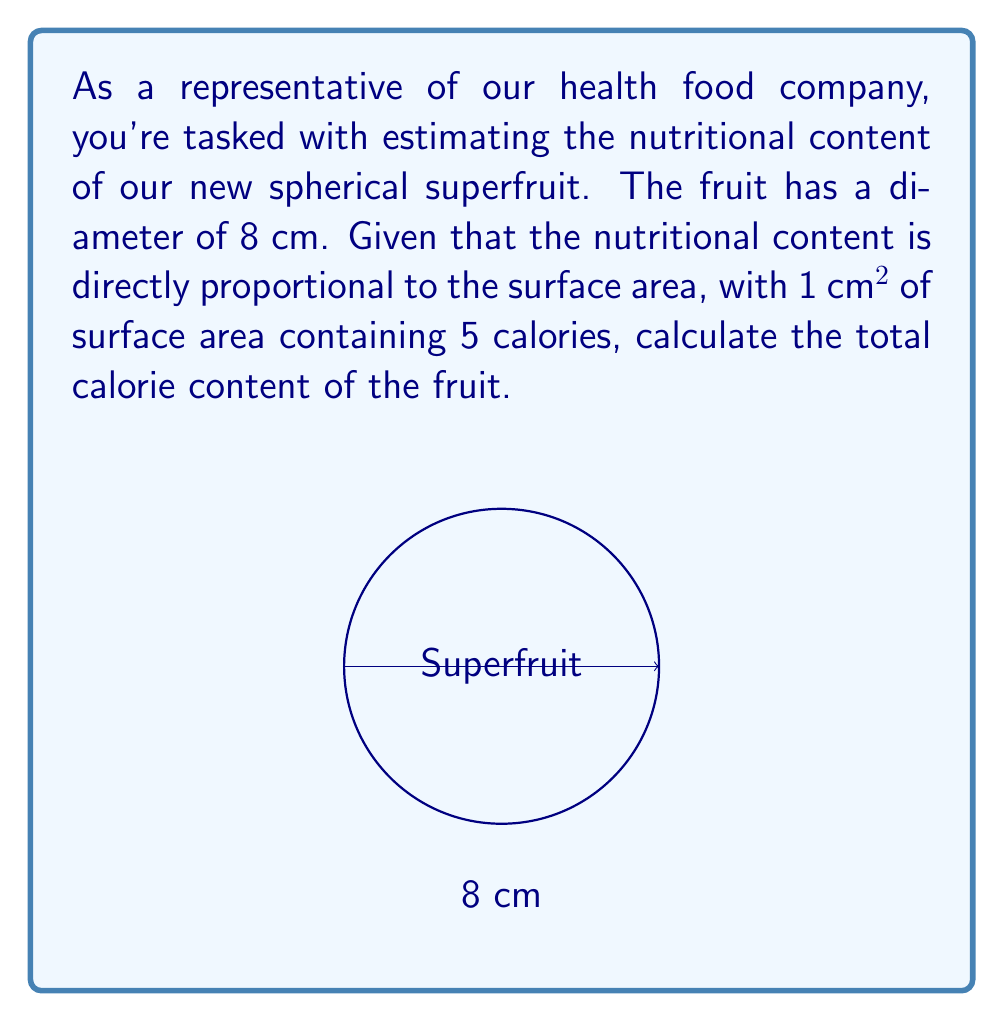Solve this math problem. To solve this problem, we need to follow these steps:

1) First, calculate the surface area of the spherical fruit.
   The formula for the surface area of a sphere is:
   $$A = 4\pi r^2$$
   where $r$ is the radius of the sphere.

2) The diameter is given as 8 cm, so the radius is 4 cm.
   
3) Substituting into the formula:
   $$A = 4\pi (4\text{ cm})^2 = 4\pi (16\text{ cm}^2) = 64\pi\text{ cm}^2$$

4) Now we need to calculate the exact value:
   $$64\pi \approx 201.06\text{ cm}^2$$

5) Given that 1 cm² contains 5 calories, we multiply the surface area by 5:
   $$201.06\text{ cm}^2 \times 5\text{ calories/cm}^2 = 1005.31\text{ calories}$$

6) Rounding to the nearest calorie:
   $$1005\text{ calories}$$
Answer: 1005 calories 